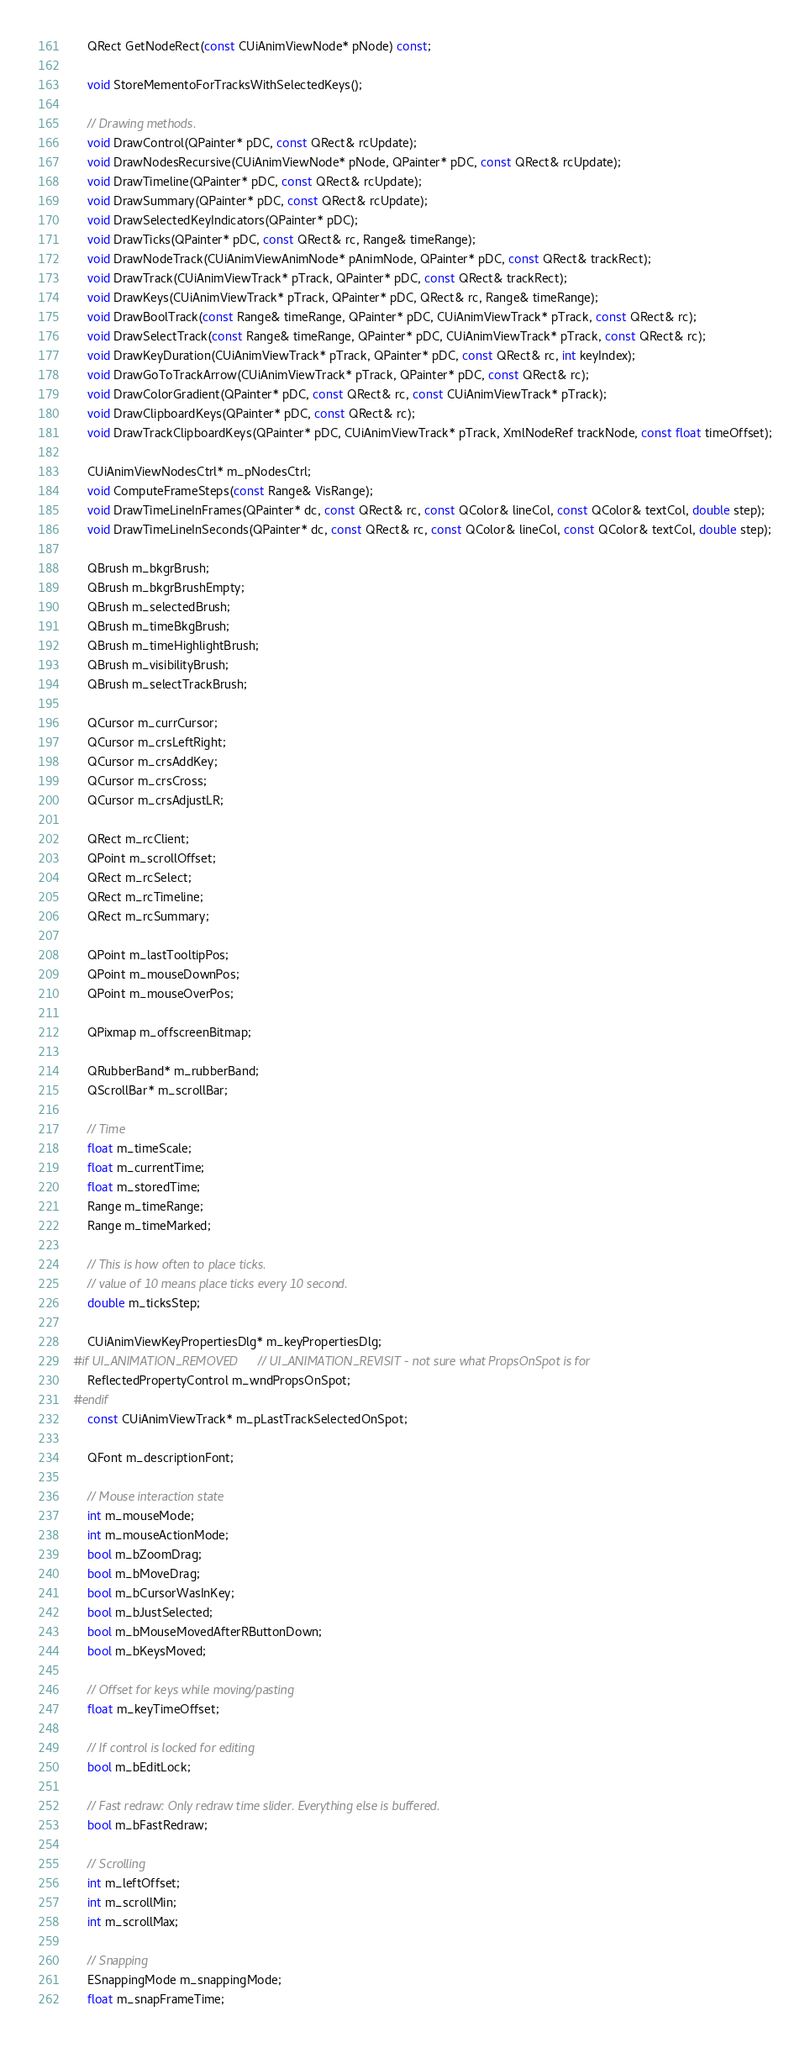Convert code to text. <code><loc_0><loc_0><loc_500><loc_500><_C_>    QRect GetNodeRect(const CUiAnimViewNode* pNode) const;

    void StoreMementoForTracksWithSelectedKeys();

    // Drawing methods.
    void DrawControl(QPainter* pDC, const QRect& rcUpdate);
    void DrawNodesRecursive(CUiAnimViewNode* pNode, QPainter* pDC, const QRect& rcUpdate);
    void DrawTimeline(QPainter* pDC, const QRect& rcUpdate);
    void DrawSummary(QPainter* pDC, const QRect& rcUpdate);
    void DrawSelectedKeyIndicators(QPainter* pDC);
    void DrawTicks(QPainter* pDC, const QRect& rc, Range& timeRange);
    void DrawNodeTrack(CUiAnimViewAnimNode* pAnimNode, QPainter* pDC, const QRect& trackRect);
    void DrawTrack(CUiAnimViewTrack* pTrack, QPainter* pDC, const QRect& trackRect);
    void DrawKeys(CUiAnimViewTrack* pTrack, QPainter* pDC, QRect& rc, Range& timeRange);
    void DrawBoolTrack(const Range& timeRange, QPainter* pDC, CUiAnimViewTrack* pTrack, const QRect& rc);
    void DrawSelectTrack(const Range& timeRange, QPainter* pDC, CUiAnimViewTrack* pTrack, const QRect& rc);
    void DrawKeyDuration(CUiAnimViewTrack* pTrack, QPainter* pDC, const QRect& rc, int keyIndex);
    void DrawGoToTrackArrow(CUiAnimViewTrack* pTrack, QPainter* pDC, const QRect& rc);
    void DrawColorGradient(QPainter* pDC, const QRect& rc, const CUiAnimViewTrack* pTrack);
    void DrawClipboardKeys(QPainter* pDC, const QRect& rc);
    void DrawTrackClipboardKeys(QPainter* pDC, CUiAnimViewTrack* pTrack, XmlNodeRef trackNode, const float timeOffset);

    CUiAnimViewNodesCtrl* m_pNodesCtrl;
    void ComputeFrameSteps(const Range& VisRange);
    void DrawTimeLineInFrames(QPainter* dc, const QRect& rc, const QColor& lineCol, const QColor& textCol, double step);
    void DrawTimeLineInSeconds(QPainter* dc, const QRect& rc, const QColor& lineCol, const QColor& textCol, double step);

    QBrush m_bkgrBrush;
    QBrush m_bkgrBrushEmpty;
    QBrush m_selectedBrush;
    QBrush m_timeBkgBrush;
    QBrush m_timeHighlightBrush;
    QBrush m_visibilityBrush;
    QBrush m_selectTrackBrush;

    QCursor m_currCursor;
    QCursor m_crsLeftRight;
    QCursor m_crsAddKey;
    QCursor m_crsCross;
    QCursor m_crsAdjustLR;

    QRect m_rcClient;
    QPoint m_scrollOffset;
    QRect m_rcSelect;
    QRect m_rcTimeline;
    QRect m_rcSummary;

    QPoint m_lastTooltipPos;
    QPoint m_mouseDownPos;
    QPoint m_mouseOverPos;

    QPixmap m_offscreenBitmap;

    QRubberBand* m_rubberBand;
    QScrollBar* m_scrollBar;

    // Time
    float m_timeScale;
    float m_currentTime;
    float m_storedTime;
    Range m_timeRange;
    Range m_timeMarked;

    // This is how often to place ticks.
    // value of 10 means place ticks every 10 second.
    double m_ticksStep;

    CUiAnimViewKeyPropertiesDlg* m_keyPropertiesDlg;
#if UI_ANIMATION_REMOVED    // UI_ANIMATION_REVISIT - not sure what PropsOnSpot is for
    ReflectedPropertyControl m_wndPropsOnSpot;
#endif
    const CUiAnimViewTrack* m_pLastTrackSelectedOnSpot;

    QFont m_descriptionFont;

    // Mouse interaction state
    int m_mouseMode;
    int m_mouseActionMode;
    bool m_bZoomDrag;
    bool m_bMoveDrag;
    bool m_bCursorWasInKey;
    bool m_bJustSelected;
    bool m_bMouseMovedAfterRButtonDown;
    bool m_bKeysMoved;

    // Offset for keys while moving/pasting
    float m_keyTimeOffset;

    // If control is locked for editing
    bool m_bEditLock;

    // Fast redraw: Only redraw time slider. Everything else is buffered.
    bool m_bFastRedraw;

    // Scrolling
    int m_leftOffset;
    int m_scrollMin;
    int m_scrollMax;

    // Snapping
    ESnappingMode m_snappingMode;
    float m_snapFrameTime;
</code> 